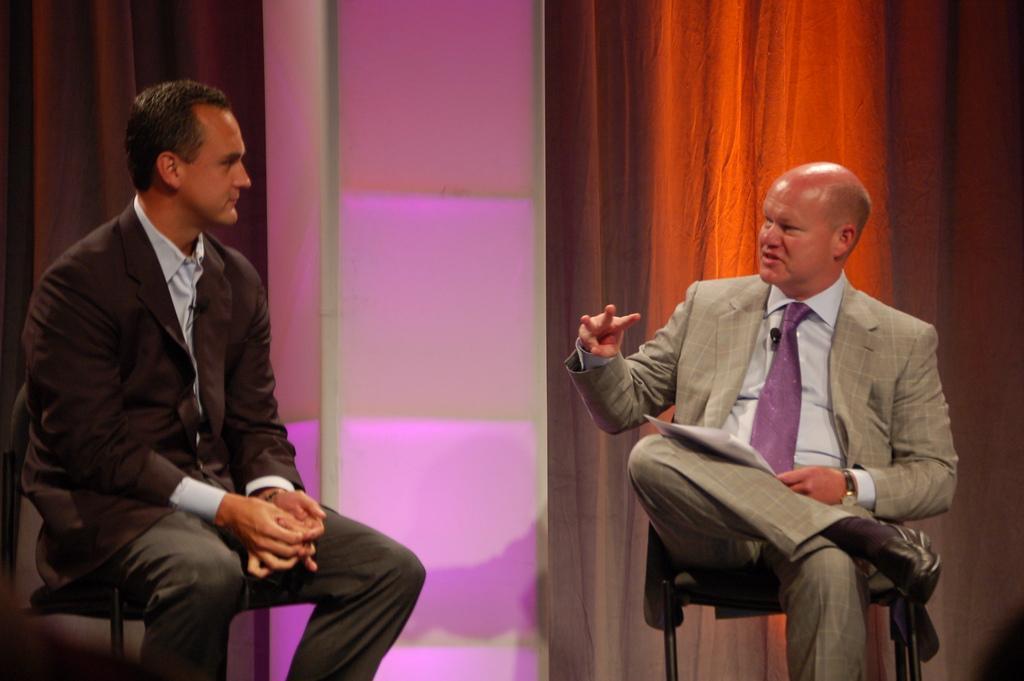Can you describe this image briefly? In the image there are two men in suits sitting on chairs and talking, behind them there is wall with lights and curtains on it. 